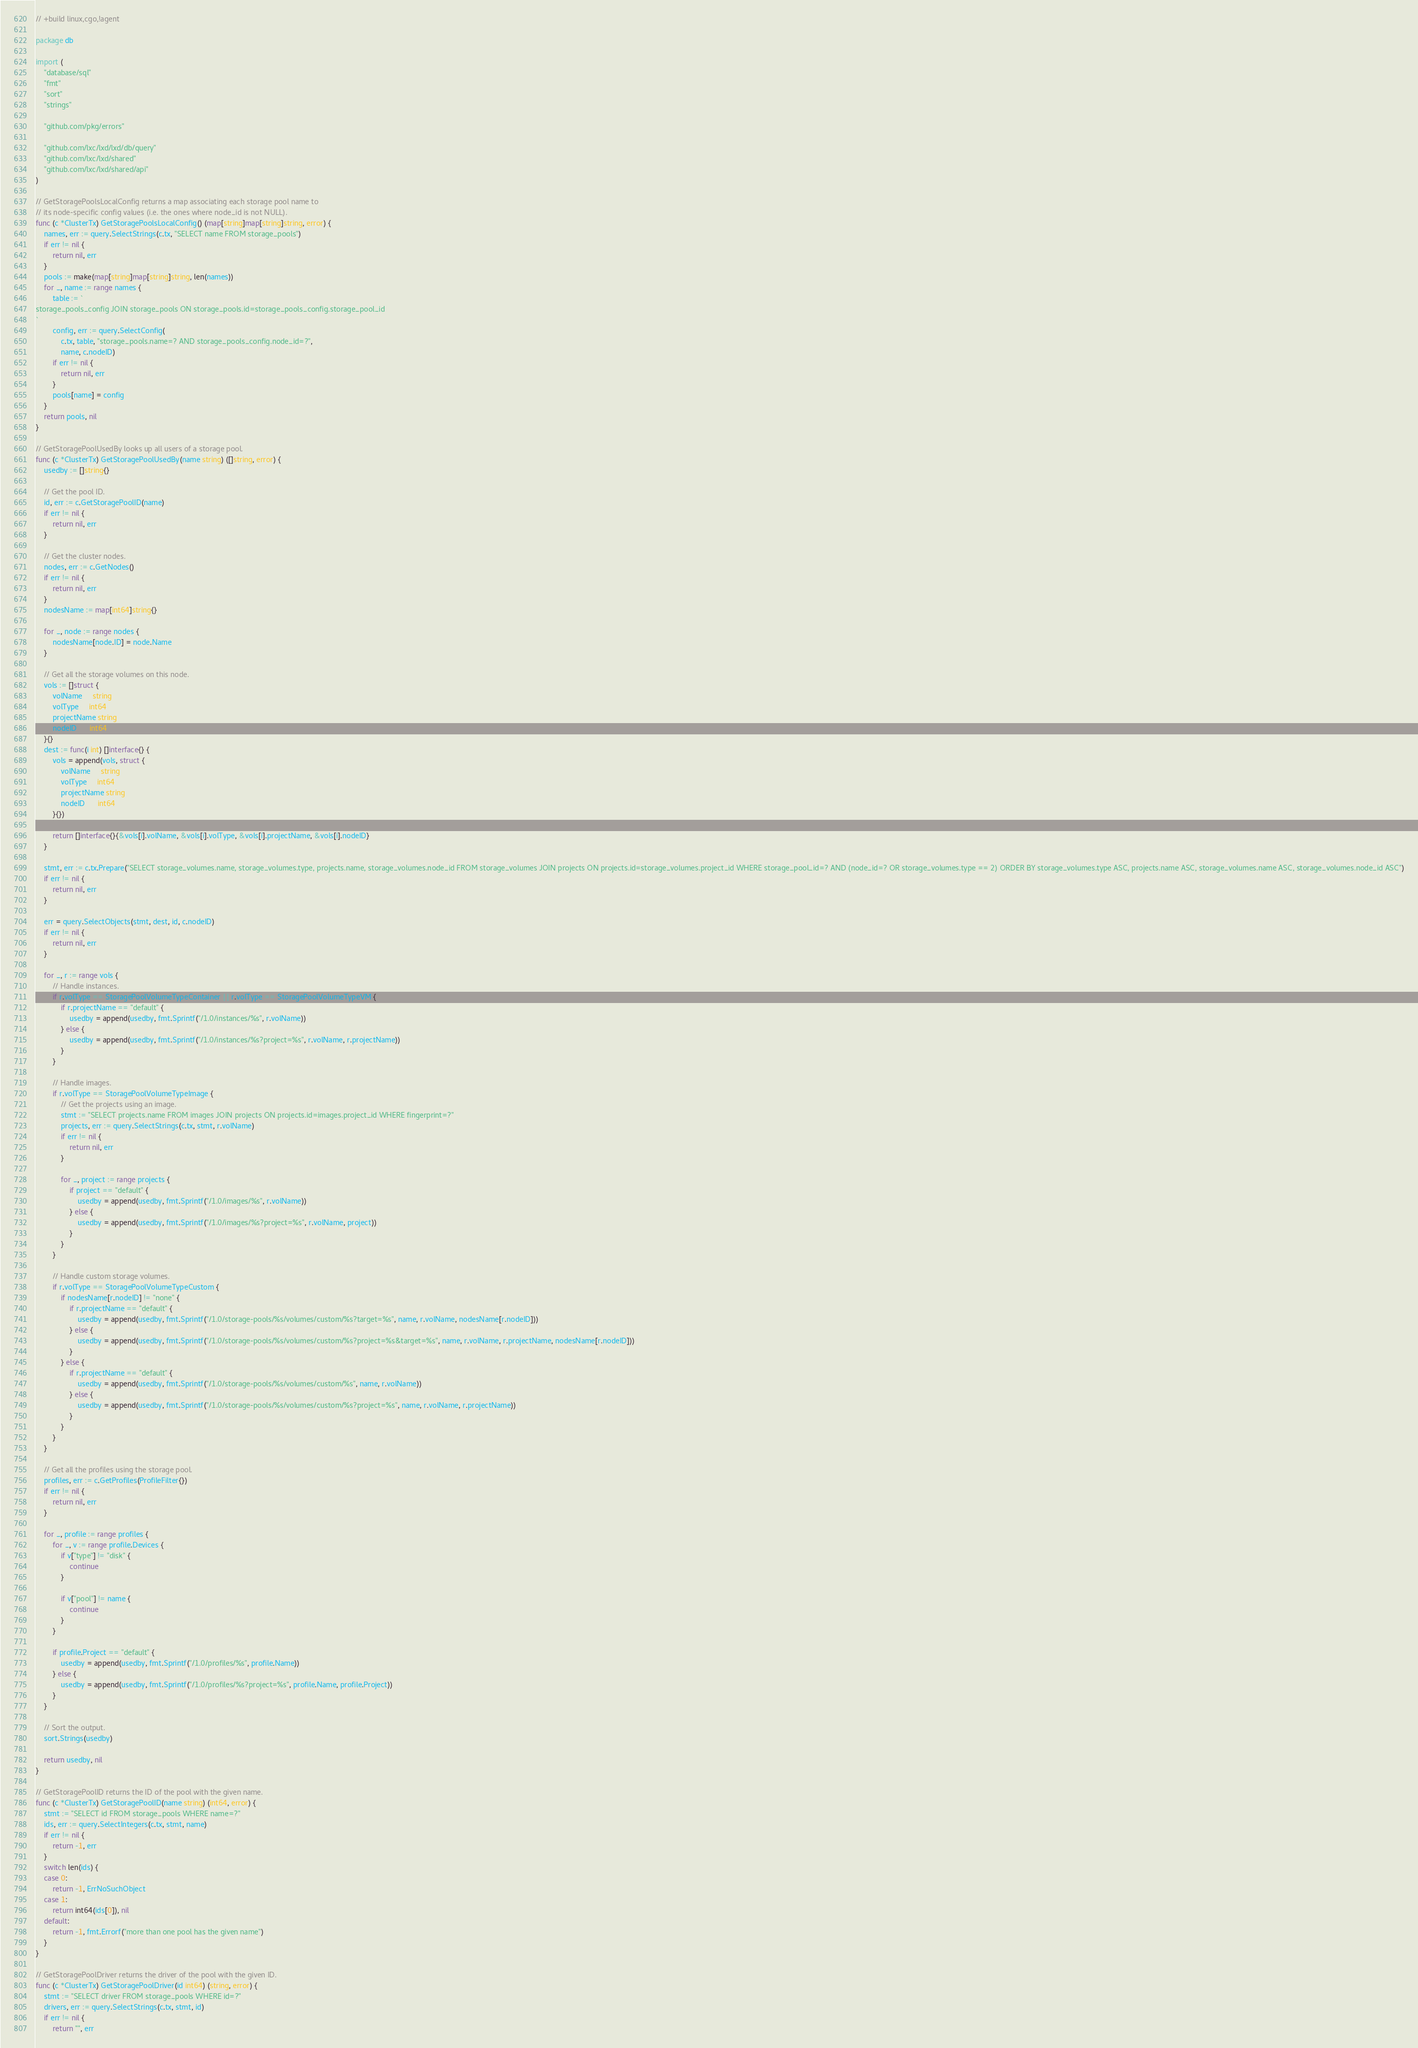Convert code to text. <code><loc_0><loc_0><loc_500><loc_500><_Go_>// +build linux,cgo,!agent

package db

import (
	"database/sql"
	"fmt"
	"sort"
	"strings"

	"github.com/pkg/errors"

	"github.com/lxc/lxd/lxd/db/query"
	"github.com/lxc/lxd/shared"
	"github.com/lxc/lxd/shared/api"
)

// GetStoragePoolsLocalConfig returns a map associating each storage pool name to
// its node-specific config values (i.e. the ones where node_id is not NULL).
func (c *ClusterTx) GetStoragePoolsLocalConfig() (map[string]map[string]string, error) {
	names, err := query.SelectStrings(c.tx, "SELECT name FROM storage_pools")
	if err != nil {
		return nil, err
	}
	pools := make(map[string]map[string]string, len(names))
	for _, name := range names {
		table := `
storage_pools_config JOIN storage_pools ON storage_pools.id=storage_pools_config.storage_pool_id
`
		config, err := query.SelectConfig(
			c.tx, table, "storage_pools.name=? AND storage_pools_config.node_id=?",
			name, c.nodeID)
		if err != nil {
			return nil, err
		}
		pools[name] = config
	}
	return pools, nil
}

// GetStoragePoolUsedBy looks up all users of a storage pool.
func (c *ClusterTx) GetStoragePoolUsedBy(name string) ([]string, error) {
	usedby := []string{}

	// Get the pool ID.
	id, err := c.GetStoragePoolID(name)
	if err != nil {
		return nil, err
	}

	// Get the cluster nodes.
	nodes, err := c.GetNodes()
	if err != nil {
		return nil, err
	}
	nodesName := map[int64]string{}

	for _, node := range nodes {
		nodesName[node.ID] = node.Name
	}

	// Get all the storage volumes on this node.
	vols := []struct {
		volName     string
		volType     int64
		projectName string
		nodeID      int64
	}{}
	dest := func(i int) []interface{} {
		vols = append(vols, struct {
			volName     string
			volType     int64
			projectName string
			nodeID      int64
		}{})

		return []interface{}{&vols[i].volName, &vols[i].volType, &vols[i].projectName, &vols[i].nodeID}
	}

	stmt, err := c.tx.Prepare("SELECT storage_volumes.name, storage_volumes.type, projects.name, storage_volumes.node_id FROM storage_volumes JOIN projects ON projects.id=storage_volumes.project_id WHERE storage_pool_id=? AND (node_id=? OR storage_volumes.type == 2) ORDER BY storage_volumes.type ASC, projects.name ASC, storage_volumes.name ASC, storage_volumes.node_id ASC")
	if err != nil {
		return nil, err
	}

	err = query.SelectObjects(stmt, dest, id, c.nodeID)
	if err != nil {
		return nil, err
	}

	for _, r := range vols {
		// Handle instances.
		if r.volType == StoragePoolVolumeTypeContainer || r.volType == StoragePoolVolumeTypeVM {
			if r.projectName == "default" {
				usedby = append(usedby, fmt.Sprintf("/1.0/instances/%s", r.volName))
			} else {
				usedby = append(usedby, fmt.Sprintf("/1.0/instances/%s?project=%s", r.volName, r.projectName))
			}
		}

		// Handle images.
		if r.volType == StoragePoolVolumeTypeImage {
			// Get the projects using an image.
			stmt := "SELECT projects.name FROM images JOIN projects ON projects.id=images.project_id WHERE fingerprint=?"
			projects, err := query.SelectStrings(c.tx, stmt, r.volName)
			if err != nil {
				return nil, err
			}

			for _, project := range projects {
				if project == "default" {
					usedby = append(usedby, fmt.Sprintf("/1.0/images/%s", r.volName))
				} else {
					usedby = append(usedby, fmt.Sprintf("/1.0/images/%s?project=%s", r.volName, project))
				}
			}
		}

		// Handle custom storage volumes.
		if r.volType == StoragePoolVolumeTypeCustom {
			if nodesName[r.nodeID] != "none" {
				if r.projectName == "default" {
					usedby = append(usedby, fmt.Sprintf("/1.0/storage-pools/%s/volumes/custom/%s?target=%s", name, r.volName, nodesName[r.nodeID]))
				} else {
					usedby = append(usedby, fmt.Sprintf("/1.0/storage-pools/%s/volumes/custom/%s?project=%s&target=%s", name, r.volName, r.projectName, nodesName[r.nodeID]))
				}
			} else {
				if r.projectName == "default" {
					usedby = append(usedby, fmt.Sprintf("/1.0/storage-pools/%s/volumes/custom/%s", name, r.volName))
				} else {
					usedby = append(usedby, fmt.Sprintf("/1.0/storage-pools/%s/volumes/custom/%s?project=%s", name, r.volName, r.projectName))
				}
			}
		}
	}

	// Get all the profiles using the storage pool.
	profiles, err := c.GetProfiles(ProfileFilter{})
	if err != nil {
		return nil, err
	}

	for _, profile := range profiles {
		for _, v := range profile.Devices {
			if v["type"] != "disk" {
				continue
			}

			if v["pool"] != name {
				continue
			}
		}

		if profile.Project == "default" {
			usedby = append(usedby, fmt.Sprintf("/1.0/profiles/%s", profile.Name))
		} else {
			usedby = append(usedby, fmt.Sprintf("/1.0/profiles/%s?project=%s", profile.Name, profile.Project))
		}
	}

	// Sort the output.
	sort.Strings(usedby)

	return usedby, nil
}

// GetStoragePoolID returns the ID of the pool with the given name.
func (c *ClusterTx) GetStoragePoolID(name string) (int64, error) {
	stmt := "SELECT id FROM storage_pools WHERE name=?"
	ids, err := query.SelectIntegers(c.tx, stmt, name)
	if err != nil {
		return -1, err
	}
	switch len(ids) {
	case 0:
		return -1, ErrNoSuchObject
	case 1:
		return int64(ids[0]), nil
	default:
		return -1, fmt.Errorf("more than one pool has the given name")
	}
}

// GetStoragePoolDriver returns the driver of the pool with the given ID.
func (c *ClusterTx) GetStoragePoolDriver(id int64) (string, error) {
	stmt := "SELECT driver FROM storage_pools WHERE id=?"
	drivers, err := query.SelectStrings(c.tx, stmt, id)
	if err != nil {
		return "", err</code> 